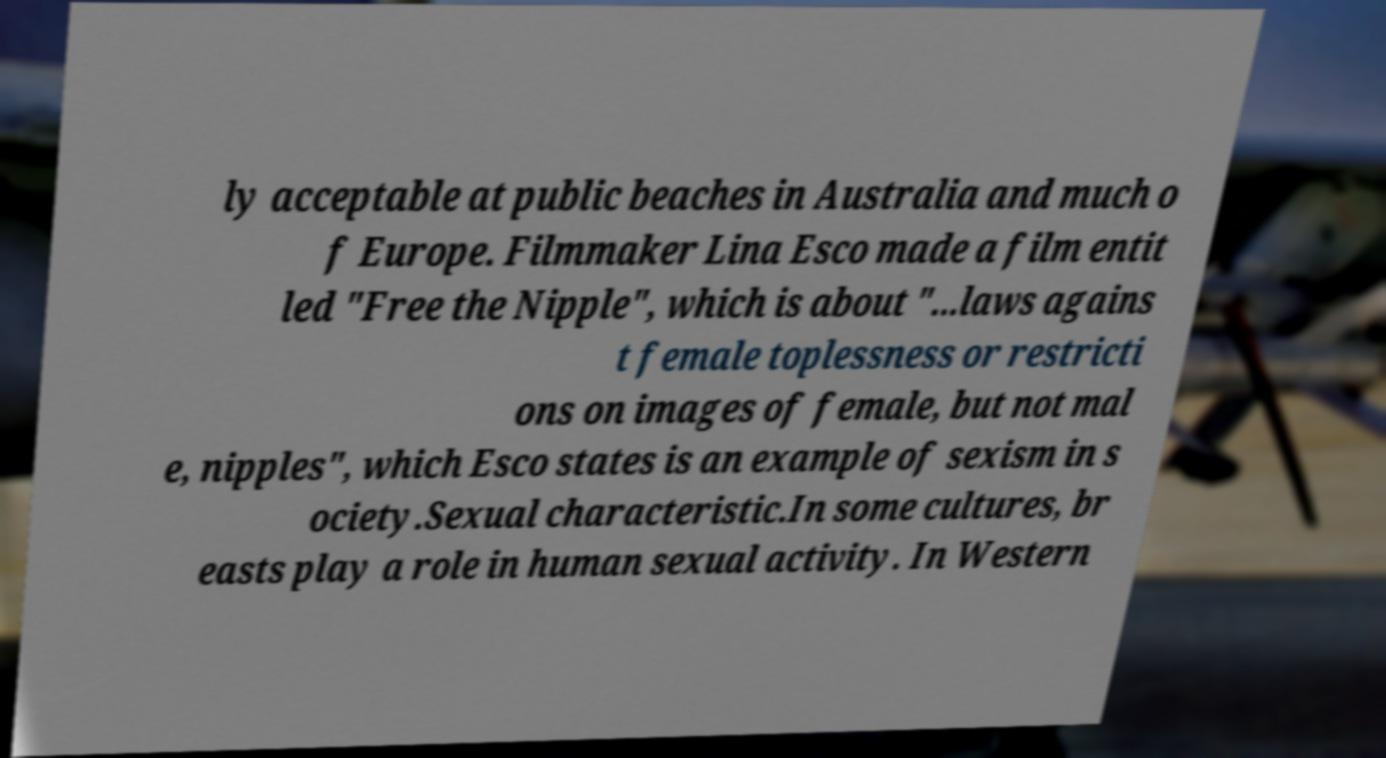Can you accurately transcribe the text from the provided image for me? ly acceptable at public beaches in Australia and much o f Europe. Filmmaker Lina Esco made a film entit led "Free the Nipple", which is about "...laws agains t female toplessness or restricti ons on images of female, but not mal e, nipples", which Esco states is an example of sexism in s ociety.Sexual characteristic.In some cultures, br easts play a role in human sexual activity. In Western 